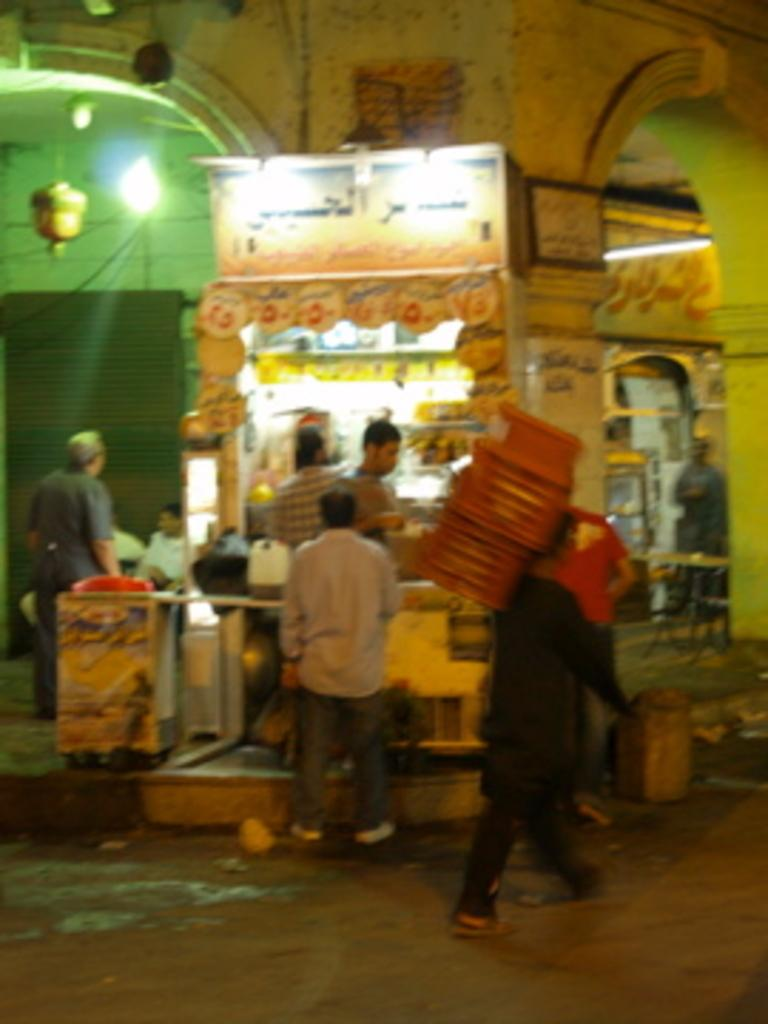Who or what can be seen in the image? There are people in the image. What type of structures are present in the image? There are stalls, boards, pillars, and a wall visible in the image. What can be used to provide illumination in the image? There are lights in the image. What is the purpose of the shutter in the image? The shutter is likely used to cover or protect a window or door. What is visible at the bottom of the image? There is a road visible at the bottom of the image. What other objects can be seen in the image? There are various objects in the image, including those related to the stalls and people. How does the knot in the image help to organize the objects? There is no knot present in the image; it is a collection of people, stalls, lights, boards, pillars, a wall, a shutter, and various objects. What route do the people take to reach the stalls in the image? The image does not provide information about the route taken by the people to reach the stalls. 